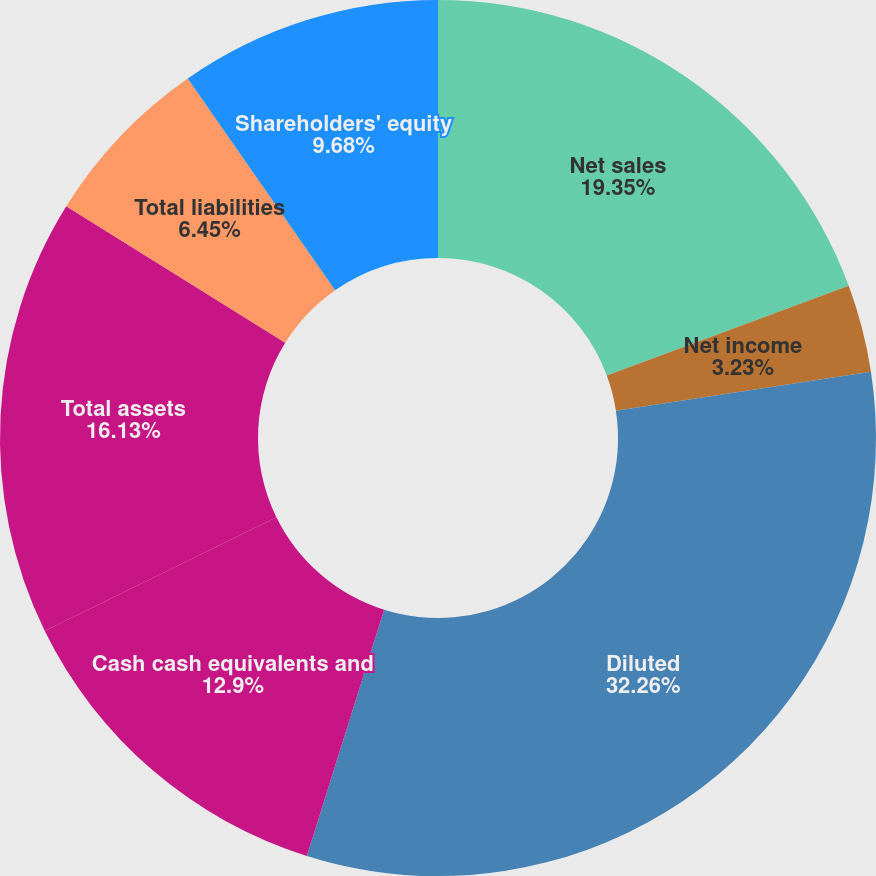Convert chart to OTSL. <chart><loc_0><loc_0><loc_500><loc_500><pie_chart><fcel>Net sales<fcel>Net income<fcel>Basic<fcel>Diluted<fcel>Cash cash equivalents and<fcel>Total assets<fcel>Total liabilities<fcel>Shareholders' equity<nl><fcel>19.35%<fcel>3.23%<fcel>0.0%<fcel>32.26%<fcel>12.9%<fcel>16.13%<fcel>6.45%<fcel>9.68%<nl></chart> 